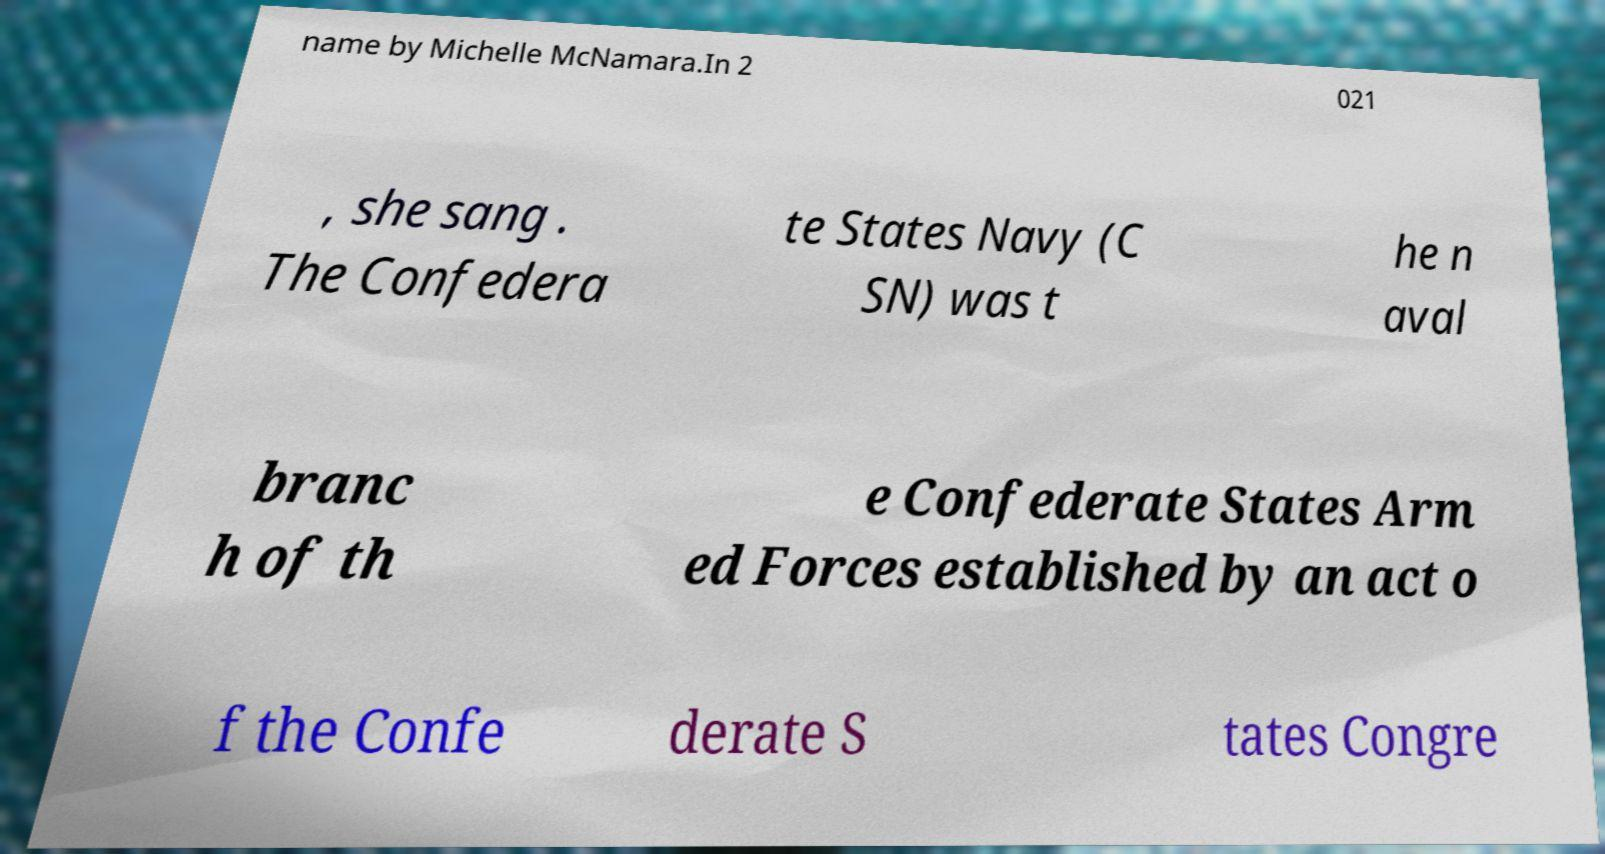Please read and relay the text visible in this image. What does it say? name by Michelle McNamara.In 2 021 , she sang . The Confedera te States Navy (C SN) was t he n aval branc h of th e Confederate States Arm ed Forces established by an act o f the Confe derate S tates Congre 